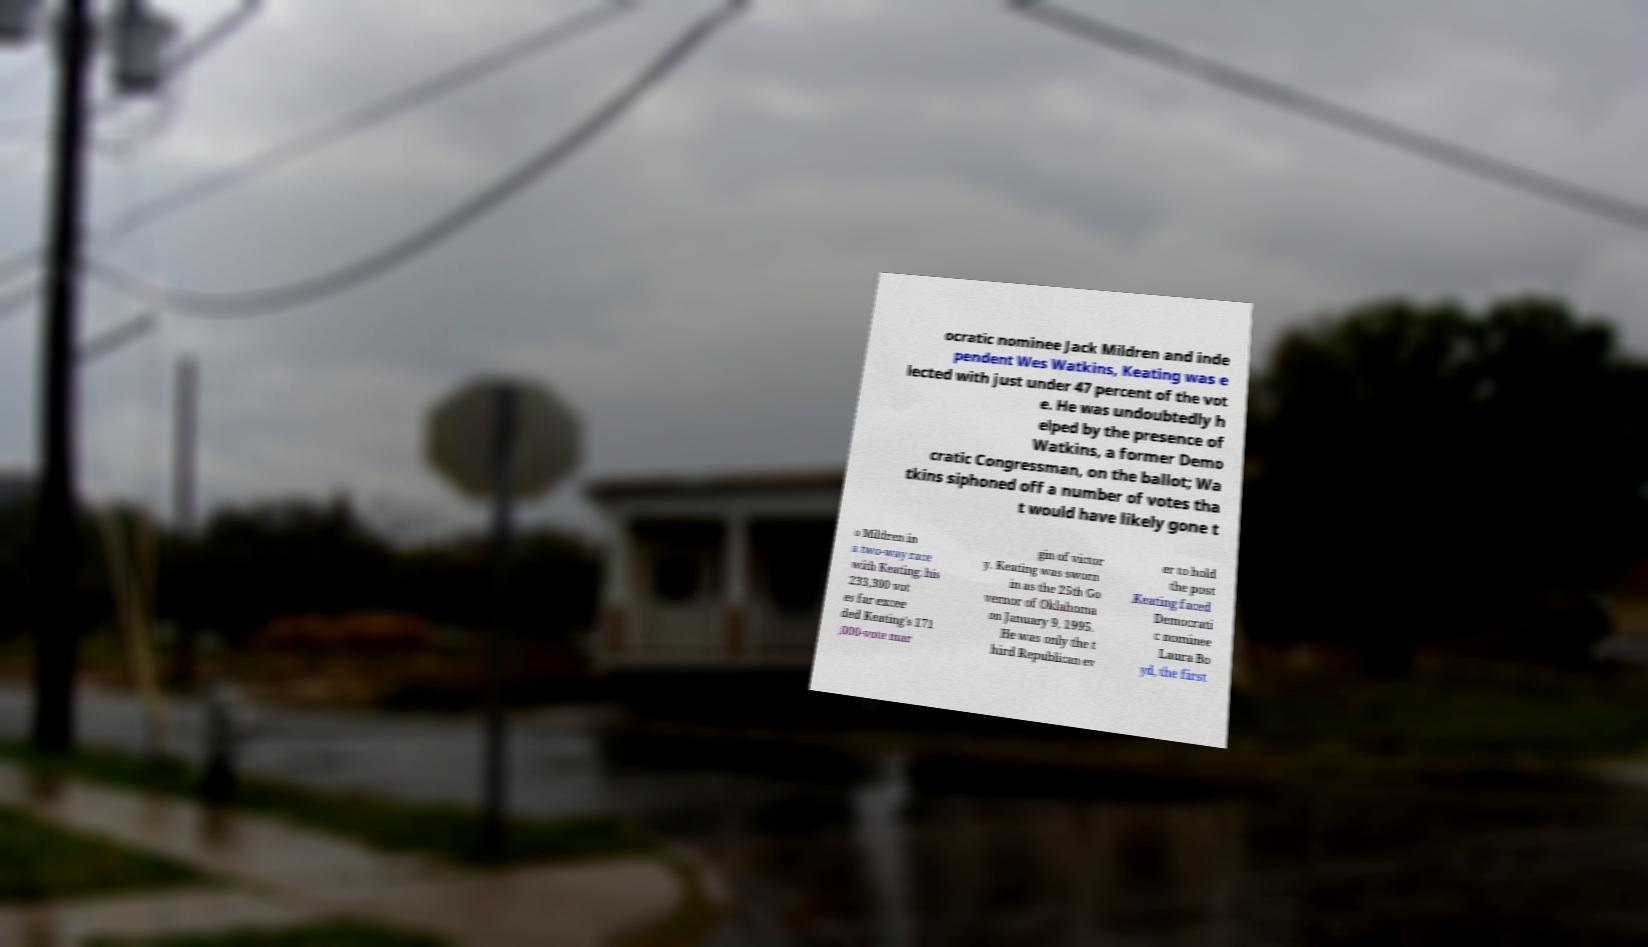What messages or text are displayed in this image? I need them in a readable, typed format. ocratic nominee Jack Mildren and inde pendent Wes Watkins, Keating was e lected with just under 47 percent of the vot e. He was undoubtedly h elped by the presence of Watkins, a former Demo cratic Congressman, on the ballot; Wa tkins siphoned off a number of votes tha t would have likely gone t o Mildren in a two-way race with Keating; his 233,300 vot es far excee ded Keating's 171 ,000-vote mar gin of victor y. Keating was sworn in as the 25th Go vernor of Oklahoma on January 9, 1995. He was only the t hird Republican ev er to hold the post .Keating faced Democrati c nominee Laura Bo yd, the first 